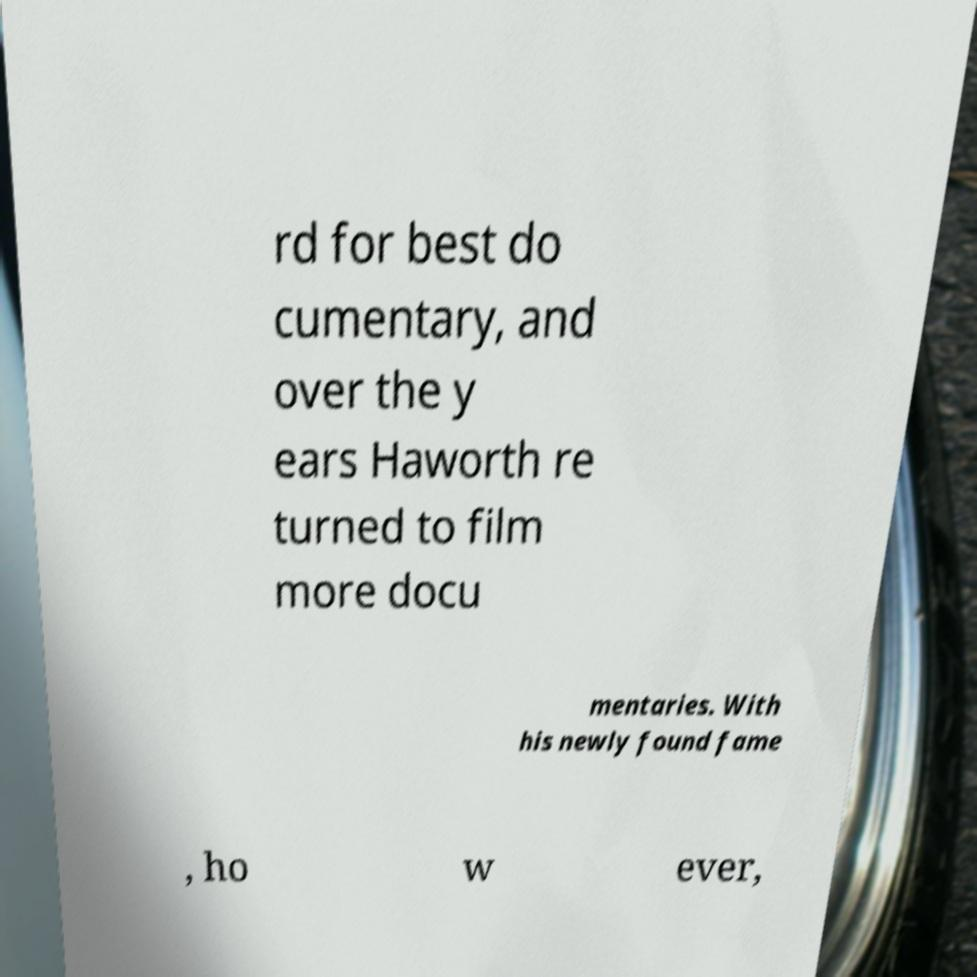I need the written content from this picture converted into text. Can you do that? rd for best do cumentary, and over the y ears Haworth re turned to film more docu mentaries. With his newly found fame , ho w ever, 